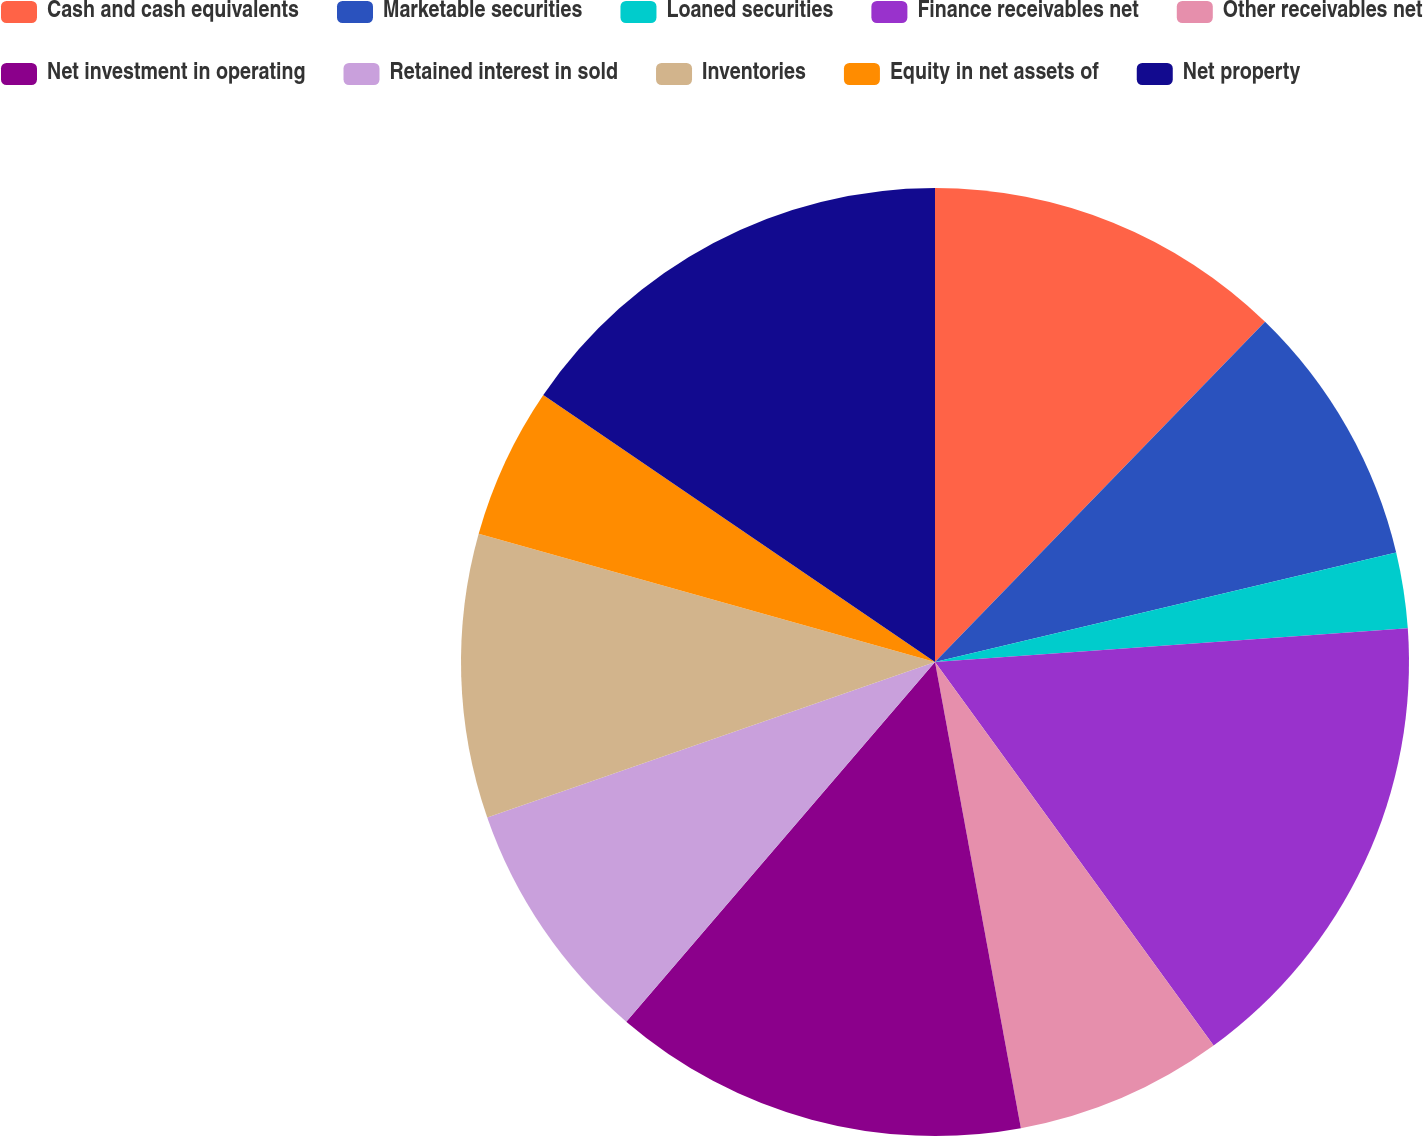Convert chart. <chart><loc_0><loc_0><loc_500><loc_500><pie_chart><fcel>Cash and cash equivalents<fcel>Marketable securities<fcel>Loaned securities<fcel>Finance receivables net<fcel>Other receivables net<fcel>Net investment in operating<fcel>Retained interest in sold<fcel>Inventories<fcel>Equity in net assets of<fcel>Net property<nl><fcel>12.26%<fcel>9.03%<fcel>2.58%<fcel>16.13%<fcel>7.1%<fcel>14.19%<fcel>8.39%<fcel>9.68%<fcel>5.16%<fcel>15.48%<nl></chart> 